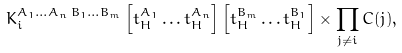<formula> <loc_0><loc_0><loc_500><loc_500>K _ { i } ^ { A _ { 1 } \dots A _ { n } \, B _ { 1 } \dots B _ { m } } \left [ t _ { H } ^ { A _ { 1 } } \dots t _ { H } ^ { A _ { n } } \right ] \left [ t _ { H } ^ { B _ { m } } \dots t _ { H } ^ { B _ { 1 } } \right ] \times \prod _ { j \neq i } C ( j ) ,</formula> 